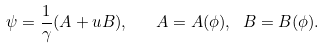<formula> <loc_0><loc_0><loc_500><loc_500>\psi = \frac { 1 } { \gamma } ( A + u B ) , \quad A = A ( \phi ) , \ B = B ( \phi ) .</formula> 